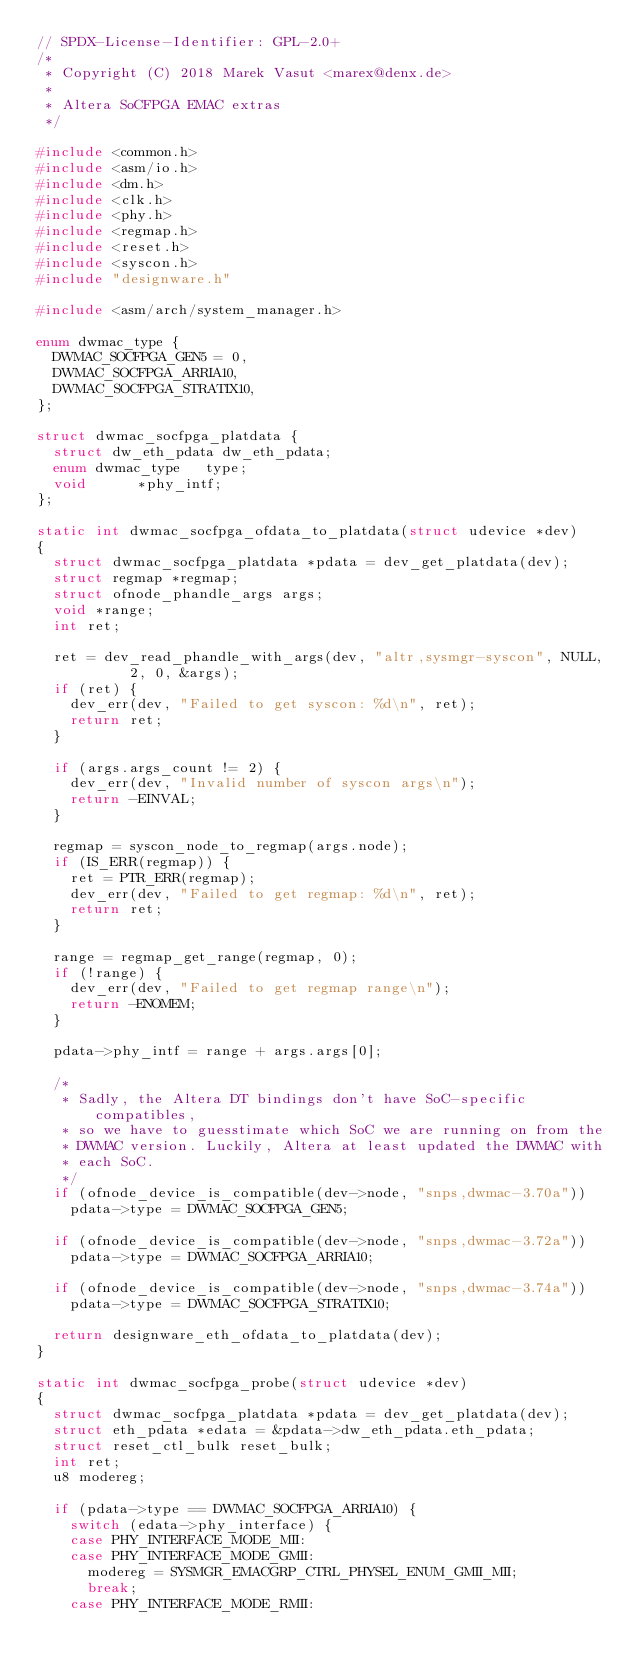Convert code to text. <code><loc_0><loc_0><loc_500><loc_500><_C_>// SPDX-License-Identifier: GPL-2.0+
/*
 * Copyright (C) 2018 Marek Vasut <marex@denx.de>
 *
 * Altera SoCFPGA EMAC extras
 */

#include <common.h>
#include <asm/io.h>
#include <dm.h>
#include <clk.h>
#include <phy.h>
#include <regmap.h>
#include <reset.h>
#include <syscon.h>
#include "designware.h"

#include <asm/arch/system_manager.h>

enum dwmac_type {
	DWMAC_SOCFPGA_GEN5 = 0,
	DWMAC_SOCFPGA_ARRIA10,
	DWMAC_SOCFPGA_STRATIX10,
};

struct dwmac_socfpga_platdata {
	struct dw_eth_pdata	dw_eth_pdata;
	enum dwmac_type		type;
	void			*phy_intf;
};

static int dwmac_socfpga_ofdata_to_platdata(struct udevice *dev)
{
	struct dwmac_socfpga_platdata *pdata = dev_get_platdata(dev);
	struct regmap *regmap;
	struct ofnode_phandle_args args;
	void *range;
	int ret;

	ret = dev_read_phandle_with_args(dev, "altr,sysmgr-syscon", NULL,
					 2, 0, &args);
	if (ret) {
		dev_err(dev, "Failed to get syscon: %d\n", ret);
		return ret;
	}

	if (args.args_count != 2) {
		dev_err(dev, "Invalid number of syscon args\n");
		return -EINVAL;
	}

	regmap = syscon_node_to_regmap(args.node);
	if (IS_ERR(regmap)) {
		ret = PTR_ERR(regmap);
		dev_err(dev, "Failed to get regmap: %d\n", ret);
		return ret;
	}

	range = regmap_get_range(regmap, 0);
	if (!range) {
		dev_err(dev, "Failed to get regmap range\n");
		return -ENOMEM;
	}

	pdata->phy_intf = range + args.args[0];

	/*
	 * Sadly, the Altera DT bindings don't have SoC-specific compatibles,
	 * so we have to guesstimate which SoC we are running on from the
	 * DWMAC version. Luckily, Altera at least updated the DWMAC with
	 * each SoC.
	 */
	if (ofnode_device_is_compatible(dev->node, "snps,dwmac-3.70a"))
		pdata->type = DWMAC_SOCFPGA_GEN5;

	if (ofnode_device_is_compatible(dev->node, "snps,dwmac-3.72a"))
		pdata->type = DWMAC_SOCFPGA_ARRIA10;

	if (ofnode_device_is_compatible(dev->node, "snps,dwmac-3.74a"))
		pdata->type = DWMAC_SOCFPGA_STRATIX10;

	return designware_eth_ofdata_to_platdata(dev);
}

static int dwmac_socfpga_probe(struct udevice *dev)
{
	struct dwmac_socfpga_platdata *pdata = dev_get_platdata(dev);
	struct eth_pdata *edata = &pdata->dw_eth_pdata.eth_pdata;
	struct reset_ctl_bulk reset_bulk;
	int ret;
	u8 modereg;

	if (pdata->type == DWMAC_SOCFPGA_ARRIA10) {
		switch (edata->phy_interface) {
		case PHY_INTERFACE_MODE_MII:
		case PHY_INTERFACE_MODE_GMII:
			modereg = SYSMGR_EMACGRP_CTRL_PHYSEL_ENUM_GMII_MII;
			break;
		case PHY_INTERFACE_MODE_RMII:</code> 